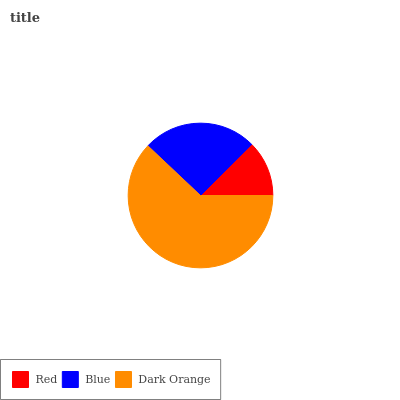Is Red the minimum?
Answer yes or no. Yes. Is Dark Orange the maximum?
Answer yes or no. Yes. Is Blue the minimum?
Answer yes or no. No. Is Blue the maximum?
Answer yes or no. No. Is Blue greater than Red?
Answer yes or no. Yes. Is Red less than Blue?
Answer yes or no. Yes. Is Red greater than Blue?
Answer yes or no. No. Is Blue less than Red?
Answer yes or no. No. Is Blue the high median?
Answer yes or no. Yes. Is Blue the low median?
Answer yes or no. Yes. Is Red the high median?
Answer yes or no. No. Is Dark Orange the low median?
Answer yes or no. No. 